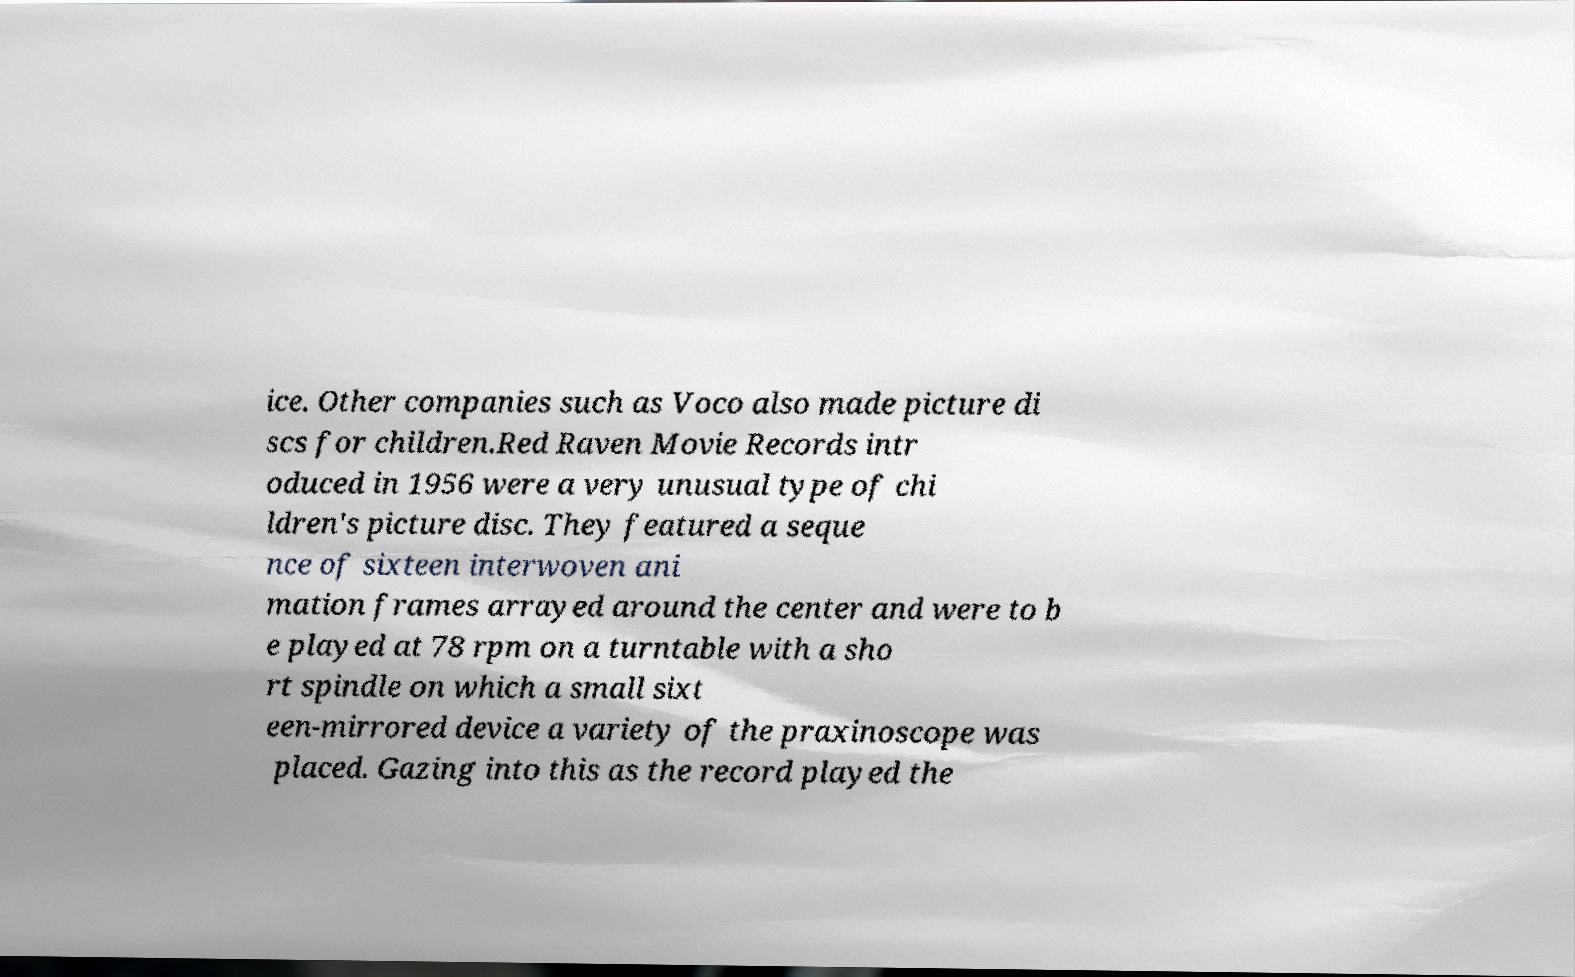What messages or text are displayed in this image? I need them in a readable, typed format. ice. Other companies such as Voco also made picture di scs for children.Red Raven Movie Records intr oduced in 1956 were a very unusual type of chi ldren's picture disc. They featured a seque nce of sixteen interwoven ani mation frames arrayed around the center and were to b e played at 78 rpm on a turntable with a sho rt spindle on which a small sixt een-mirrored device a variety of the praxinoscope was placed. Gazing into this as the record played the 